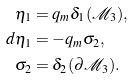Convert formula to latex. <formula><loc_0><loc_0><loc_500><loc_500>\eta _ { 1 } & = q _ { m } \delta _ { 1 } ( \mathcal { M } _ { 3 } ) , \\ d \eta _ { 1 } & = - q _ { m } \sigma _ { 2 } , \\ \sigma _ { 2 } & = \delta _ { 2 } ( \partial \mathcal { M } _ { 3 } ) .</formula> 